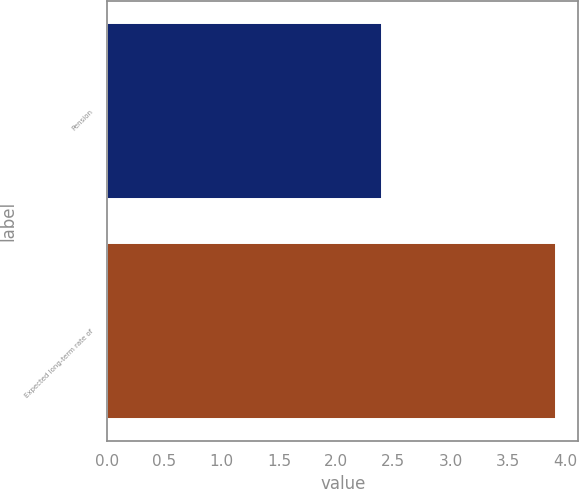<chart> <loc_0><loc_0><loc_500><loc_500><bar_chart><fcel>Pension<fcel>Expected long-term rate of<nl><fcel>2.4<fcel>3.92<nl></chart> 